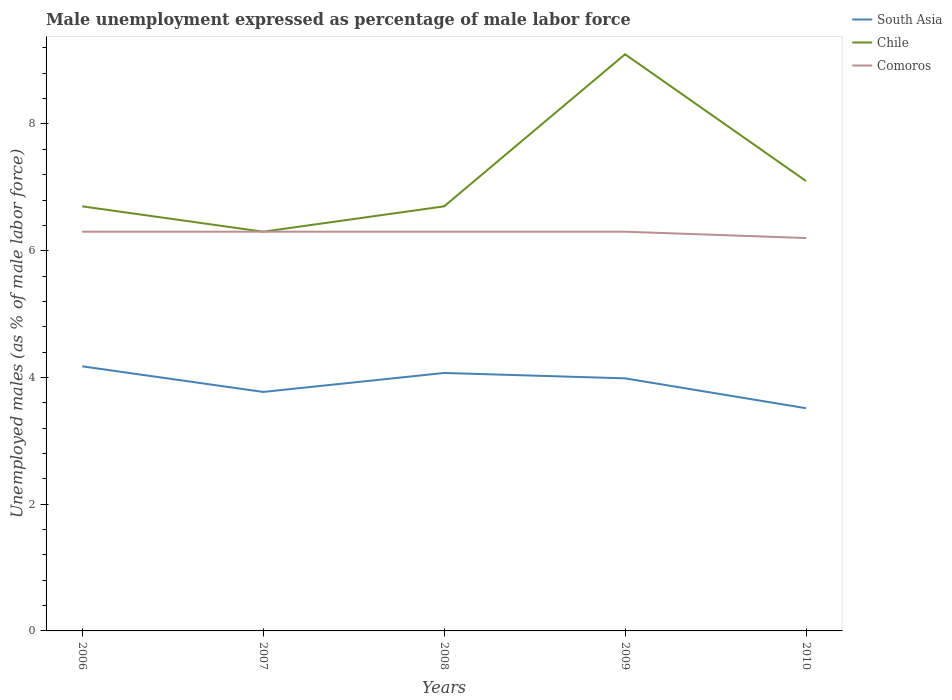How many different coloured lines are there?
Your response must be concise. 3. Does the line corresponding to Chile intersect with the line corresponding to Comoros?
Ensure brevity in your answer.  Yes. Is the number of lines equal to the number of legend labels?
Ensure brevity in your answer.  Yes. Across all years, what is the maximum unemployment in males in in South Asia?
Your answer should be very brief. 3.51. What is the total unemployment in males in in Comoros in the graph?
Keep it short and to the point. 0. What is the difference between the highest and the second highest unemployment in males in in South Asia?
Keep it short and to the point. 0.66. What is the difference between the highest and the lowest unemployment in males in in Comoros?
Give a very brief answer. 4. Is the unemployment in males in in Chile strictly greater than the unemployment in males in in South Asia over the years?
Provide a succinct answer. No. How many years are there in the graph?
Your answer should be compact. 5. Where does the legend appear in the graph?
Provide a succinct answer. Top right. What is the title of the graph?
Make the answer very short. Male unemployment expressed as percentage of male labor force. What is the label or title of the X-axis?
Your answer should be compact. Years. What is the label or title of the Y-axis?
Provide a short and direct response. Unemployed males (as % of male labor force). What is the Unemployed males (as % of male labor force) in South Asia in 2006?
Offer a terse response. 4.18. What is the Unemployed males (as % of male labor force) in Chile in 2006?
Ensure brevity in your answer.  6.7. What is the Unemployed males (as % of male labor force) in Comoros in 2006?
Your answer should be very brief. 6.3. What is the Unemployed males (as % of male labor force) in South Asia in 2007?
Provide a short and direct response. 3.77. What is the Unemployed males (as % of male labor force) in Chile in 2007?
Offer a very short reply. 6.3. What is the Unemployed males (as % of male labor force) of Comoros in 2007?
Offer a very short reply. 6.3. What is the Unemployed males (as % of male labor force) of South Asia in 2008?
Ensure brevity in your answer.  4.07. What is the Unemployed males (as % of male labor force) of Chile in 2008?
Give a very brief answer. 6.7. What is the Unemployed males (as % of male labor force) in Comoros in 2008?
Keep it short and to the point. 6.3. What is the Unemployed males (as % of male labor force) of South Asia in 2009?
Make the answer very short. 3.99. What is the Unemployed males (as % of male labor force) of Chile in 2009?
Offer a very short reply. 9.1. What is the Unemployed males (as % of male labor force) of Comoros in 2009?
Make the answer very short. 6.3. What is the Unemployed males (as % of male labor force) in South Asia in 2010?
Offer a very short reply. 3.51. What is the Unemployed males (as % of male labor force) in Chile in 2010?
Make the answer very short. 7.1. What is the Unemployed males (as % of male labor force) of Comoros in 2010?
Offer a terse response. 6.2. Across all years, what is the maximum Unemployed males (as % of male labor force) of South Asia?
Provide a succinct answer. 4.18. Across all years, what is the maximum Unemployed males (as % of male labor force) in Chile?
Ensure brevity in your answer.  9.1. Across all years, what is the maximum Unemployed males (as % of male labor force) of Comoros?
Provide a short and direct response. 6.3. Across all years, what is the minimum Unemployed males (as % of male labor force) in South Asia?
Ensure brevity in your answer.  3.51. Across all years, what is the minimum Unemployed males (as % of male labor force) in Chile?
Your answer should be very brief. 6.3. Across all years, what is the minimum Unemployed males (as % of male labor force) of Comoros?
Provide a short and direct response. 6.2. What is the total Unemployed males (as % of male labor force) of South Asia in the graph?
Your answer should be compact. 19.52. What is the total Unemployed males (as % of male labor force) of Chile in the graph?
Your response must be concise. 35.9. What is the total Unemployed males (as % of male labor force) in Comoros in the graph?
Provide a short and direct response. 31.4. What is the difference between the Unemployed males (as % of male labor force) of South Asia in 2006 and that in 2007?
Offer a very short reply. 0.4. What is the difference between the Unemployed males (as % of male labor force) of Comoros in 2006 and that in 2007?
Make the answer very short. 0. What is the difference between the Unemployed males (as % of male labor force) of South Asia in 2006 and that in 2008?
Provide a succinct answer. 0.1. What is the difference between the Unemployed males (as % of male labor force) in Chile in 2006 and that in 2008?
Your answer should be compact. 0. What is the difference between the Unemployed males (as % of male labor force) in South Asia in 2006 and that in 2009?
Your response must be concise. 0.19. What is the difference between the Unemployed males (as % of male labor force) in Chile in 2006 and that in 2009?
Keep it short and to the point. -2.4. What is the difference between the Unemployed males (as % of male labor force) in Comoros in 2006 and that in 2009?
Keep it short and to the point. 0. What is the difference between the Unemployed males (as % of male labor force) in South Asia in 2006 and that in 2010?
Your answer should be compact. 0.66. What is the difference between the Unemployed males (as % of male labor force) in Chile in 2006 and that in 2010?
Keep it short and to the point. -0.4. What is the difference between the Unemployed males (as % of male labor force) of Comoros in 2006 and that in 2010?
Your response must be concise. 0.1. What is the difference between the Unemployed males (as % of male labor force) in South Asia in 2007 and that in 2008?
Ensure brevity in your answer.  -0.3. What is the difference between the Unemployed males (as % of male labor force) of South Asia in 2007 and that in 2009?
Your answer should be compact. -0.21. What is the difference between the Unemployed males (as % of male labor force) of Comoros in 2007 and that in 2009?
Your response must be concise. 0. What is the difference between the Unemployed males (as % of male labor force) of South Asia in 2007 and that in 2010?
Provide a short and direct response. 0.26. What is the difference between the Unemployed males (as % of male labor force) in South Asia in 2008 and that in 2009?
Keep it short and to the point. 0.09. What is the difference between the Unemployed males (as % of male labor force) of Comoros in 2008 and that in 2009?
Make the answer very short. 0. What is the difference between the Unemployed males (as % of male labor force) in South Asia in 2008 and that in 2010?
Ensure brevity in your answer.  0.56. What is the difference between the Unemployed males (as % of male labor force) of South Asia in 2009 and that in 2010?
Give a very brief answer. 0.47. What is the difference between the Unemployed males (as % of male labor force) in South Asia in 2006 and the Unemployed males (as % of male labor force) in Chile in 2007?
Provide a short and direct response. -2.12. What is the difference between the Unemployed males (as % of male labor force) in South Asia in 2006 and the Unemployed males (as % of male labor force) in Comoros in 2007?
Offer a terse response. -2.12. What is the difference between the Unemployed males (as % of male labor force) in Chile in 2006 and the Unemployed males (as % of male labor force) in Comoros in 2007?
Your response must be concise. 0.4. What is the difference between the Unemployed males (as % of male labor force) of South Asia in 2006 and the Unemployed males (as % of male labor force) of Chile in 2008?
Your answer should be compact. -2.52. What is the difference between the Unemployed males (as % of male labor force) of South Asia in 2006 and the Unemployed males (as % of male labor force) of Comoros in 2008?
Provide a short and direct response. -2.12. What is the difference between the Unemployed males (as % of male labor force) in Chile in 2006 and the Unemployed males (as % of male labor force) in Comoros in 2008?
Your response must be concise. 0.4. What is the difference between the Unemployed males (as % of male labor force) in South Asia in 2006 and the Unemployed males (as % of male labor force) in Chile in 2009?
Your answer should be very brief. -4.92. What is the difference between the Unemployed males (as % of male labor force) in South Asia in 2006 and the Unemployed males (as % of male labor force) in Comoros in 2009?
Your answer should be compact. -2.12. What is the difference between the Unemployed males (as % of male labor force) of Chile in 2006 and the Unemployed males (as % of male labor force) of Comoros in 2009?
Offer a terse response. 0.4. What is the difference between the Unemployed males (as % of male labor force) in South Asia in 2006 and the Unemployed males (as % of male labor force) in Chile in 2010?
Your response must be concise. -2.92. What is the difference between the Unemployed males (as % of male labor force) in South Asia in 2006 and the Unemployed males (as % of male labor force) in Comoros in 2010?
Give a very brief answer. -2.02. What is the difference between the Unemployed males (as % of male labor force) of Chile in 2006 and the Unemployed males (as % of male labor force) of Comoros in 2010?
Give a very brief answer. 0.5. What is the difference between the Unemployed males (as % of male labor force) in South Asia in 2007 and the Unemployed males (as % of male labor force) in Chile in 2008?
Give a very brief answer. -2.93. What is the difference between the Unemployed males (as % of male labor force) of South Asia in 2007 and the Unemployed males (as % of male labor force) of Comoros in 2008?
Your answer should be very brief. -2.53. What is the difference between the Unemployed males (as % of male labor force) of Chile in 2007 and the Unemployed males (as % of male labor force) of Comoros in 2008?
Offer a very short reply. 0. What is the difference between the Unemployed males (as % of male labor force) of South Asia in 2007 and the Unemployed males (as % of male labor force) of Chile in 2009?
Your answer should be very brief. -5.33. What is the difference between the Unemployed males (as % of male labor force) in South Asia in 2007 and the Unemployed males (as % of male labor force) in Comoros in 2009?
Keep it short and to the point. -2.53. What is the difference between the Unemployed males (as % of male labor force) in Chile in 2007 and the Unemployed males (as % of male labor force) in Comoros in 2009?
Provide a short and direct response. 0. What is the difference between the Unemployed males (as % of male labor force) of South Asia in 2007 and the Unemployed males (as % of male labor force) of Chile in 2010?
Your answer should be compact. -3.33. What is the difference between the Unemployed males (as % of male labor force) of South Asia in 2007 and the Unemployed males (as % of male labor force) of Comoros in 2010?
Ensure brevity in your answer.  -2.43. What is the difference between the Unemployed males (as % of male labor force) of Chile in 2007 and the Unemployed males (as % of male labor force) of Comoros in 2010?
Offer a very short reply. 0.1. What is the difference between the Unemployed males (as % of male labor force) in South Asia in 2008 and the Unemployed males (as % of male labor force) in Chile in 2009?
Offer a terse response. -5.03. What is the difference between the Unemployed males (as % of male labor force) in South Asia in 2008 and the Unemployed males (as % of male labor force) in Comoros in 2009?
Ensure brevity in your answer.  -2.23. What is the difference between the Unemployed males (as % of male labor force) of South Asia in 2008 and the Unemployed males (as % of male labor force) of Chile in 2010?
Your answer should be compact. -3.03. What is the difference between the Unemployed males (as % of male labor force) of South Asia in 2008 and the Unemployed males (as % of male labor force) of Comoros in 2010?
Make the answer very short. -2.13. What is the difference between the Unemployed males (as % of male labor force) of Chile in 2008 and the Unemployed males (as % of male labor force) of Comoros in 2010?
Offer a terse response. 0.5. What is the difference between the Unemployed males (as % of male labor force) in South Asia in 2009 and the Unemployed males (as % of male labor force) in Chile in 2010?
Your answer should be compact. -3.11. What is the difference between the Unemployed males (as % of male labor force) of South Asia in 2009 and the Unemployed males (as % of male labor force) of Comoros in 2010?
Offer a very short reply. -2.21. What is the difference between the Unemployed males (as % of male labor force) in Chile in 2009 and the Unemployed males (as % of male labor force) in Comoros in 2010?
Your response must be concise. 2.9. What is the average Unemployed males (as % of male labor force) of South Asia per year?
Provide a succinct answer. 3.9. What is the average Unemployed males (as % of male labor force) in Chile per year?
Ensure brevity in your answer.  7.18. What is the average Unemployed males (as % of male labor force) of Comoros per year?
Provide a short and direct response. 6.28. In the year 2006, what is the difference between the Unemployed males (as % of male labor force) in South Asia and Unemployed males (as % of male labor force) in Chile?
Provide a short and direct response. -2.52. In the year 2006, what is the difference between the Unemployed males (as % of male labor force) in South Asia and Unemployed males (as % of male labor force) in Comoros?
Make the answer very short. -2.12. In the year 2007, what is the difference between the Unemployed males (as % of male labor force) of South Asia and Unemployed males (as % of male labor force) of Chile?
Your answer should be compact. -2.53. In the year 2007, what is the difference between the Unemployed males (as % of male labor force) of South Asia and Unemployed males (as % of male labor force) of Comoros?
Provide a short and direct response. -2.53. In the year 2008, what is the difference between the Unemployed males (as % of male labor force) in South Asia and Unemployed males (as % of male labor force) in Chile?
Give a very brief answer. -2.63. In the year 2008, what is the difference between the Unemployed males (as % of male labor force) of South Asia and Unemployed males (as % of male labor force) of Comoros?
Offer a very short reply. -2.23. In the year 2008, what is the difference between the Unemployed males (as % of male labor force) of Chile and Unemployed males (as % of male labor force) of Comoros?
Your answer should be compact. 0.4. In the year 2009, what is the difference between the Unemployed males (as % of male labor force) in South Asia and Unemployed males (as % of male labor force) in Chile?
Make the answer very short. -5.11. In the year 2009, what is the difference between the Unemployed males (as % of male labor force) in South Asia and Unemployed males (as % of male labor force) in Comoros?
Provide a short and direct response. -2.31. In the year 2010, what is the difference between the Unemployed males (as % of male labor force) of South Asia and Unemployed males (as % of male labor force) of Chile?
Offer a terse response. -3.59. In the year 2010, what is the difference between the Unemployed males (as % of male labor force) of South Asia and Unemployed males (as % of male labor force) of Comoros?
Provide a succinct answer. -2.69. In the year 2010, what is the difference between the Unemployed males (as % of male labor force) in Chile and Unemployed males (as % of male labor force) in Comoros?
Keep it short and to the point. 0.9. What is the ratio of the Unemployed males (as % of male labor force) in South Asia in 2006 to that in 2007?
Offer a very short reply. 1.11. What is the ratio of the Unemployed males (as % of male labor force) in Chile in 2006 to that in 2007?
Make the answer very short. 1.06. What is the ratio of the Unemployed males (as % of male labor force) in Comoros in 2006 to that in 2007?
Offer a terse response. 1. What is the ratio of the Unemployed males (as % of male labor force) of South Asia in 2006 to that in 2008?
Your answer should be very brief. 1.03. What is the ratio of the Unemployed males (as % of male labor force) of South Asia in 2006 to that in 2009?
Your response must be concise. 1.05. What is the ratio of the Unemployed males (as % of male labor force) in Chile in 2006 to that in 2009?
Give a very brief answer. 0.74. What is the ratio of the Unemployed males (as % of male labor force) of South Asia in 2006 to that in 2010?
Your answer should be very brief. 1.19. What is the ratio of the Unemployed males (as % of male labor force) in Chile in 2006 to that in 2010?
Your answer should be compact. 0.94. What is the ratio of the Unemployed males (as % of male labor force) in Comoros in 2006 to that in 2010?
Provide a succinct answer. 1.02. What is the ratio of the Unemployed males (as % of male labor force) of South Asia in 2007 to that in 2008?
Give a very brief answer. 0.93. What is the ratio of the Unemployed males (as % of male labor force) of Chile in 2007 to that in 2008?
Your answer should be compact. 0.94. What is the ratio of the Unemployed males (as % of male labor force) of Comoros in 2007 to that in 2008?
Make the answer very short. 1. What is the ratio of the Unemployed males (as % of male labor force) in South Asia in 2007 to that in 2009?
Give a very brief answer. 0.95. What is the ratio of the Unemployed males (as % of male labor force) of Chile in 2007 to that in 2009?
Provide a succinct answer. 0.69. What is the ratio of the Unemployed males (as % of male labor force) of South Asia in 2007 to that in 2010?
Offer a very short reply. 1.07. What is the ratio of the Unemployed males (as % of male labor force) in Chile in 2007 to that in 2010?
Give a very brief answer. 0.89. What is the ratio of the Unemployed males (as % of male labor force) of Comoros in 2007 to that in 2010?
Your response must be concise. 1.02. What is the ratio of the Unemployed males (as % of male labor force) of South Asia in 2008 to that in 2009?
Your response must be concise. 1.02. What is the ratio of the Unemployed males (as % of male labor force) of Chile in 2008 to that in 2009?
Make the answer very short. 0.74. What is the ratio of the Unemployed males (as % of male labor force) in South Asia in 2008 to that in 2010?
Ensure brevity in your answer.  1.16. What is the ratio of the Unemployed males (as % of male labor force) of Chile in 2008 to that in 2010?
Your answer should be compact. 0.94. What is the ratio of the Unemployed males (as % of male labor force) of Comoros in 2008 to that in 2010?
Provide a short and direct response. 1.02. What is the ratio of the Unemployed males (as % of male labor force) of South Asia in 2009 to that in 2010?
Your response must be concise. 1.13. What is the ratio of the Unemployed males (as % of male labor force) of Chile in 2009 to that in 2010?
Give a very brief answer. 1.28. What is the ratio of the Unemployed males (as % of male labor force) in Comoros in 2009 to that in 2010?
Provide a short and direct response. 1.02. What is the difference between the highest and the second highest Unemployed males (as % of male labor force) in South Asia?
Make the answer very short. 0.1. What is the difference between the highest and the second highest Unemployed males (as % of male labor force) in Chile?
Your response must be concise. 2. What is the difference between the highest and the second highest Unemployed males (as % of male labor force) of Comoros?
Your answer should be compact. 0. What is the difference between the highest and the lowest Unemployed males (as % of male labor force) in South Asia?
Ensure brevity in your answer.  0.66. What is the difference between the highest and the lowest Unemployed males (as % of male labor force) of Comoros?
Make the answer very short. 0.1. 